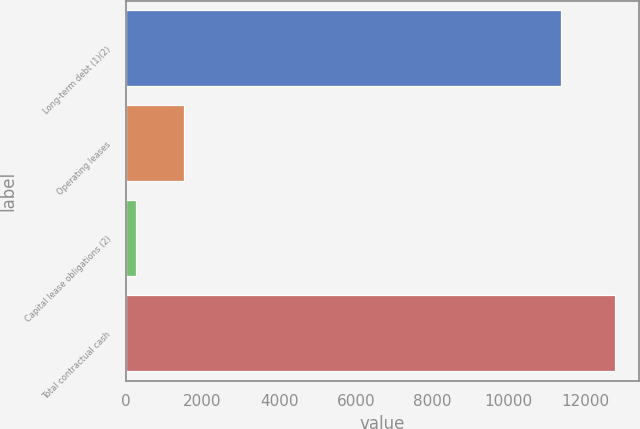<chart> <loc_0><loc_0><loc_500><loc_500><bar_chart><fcel>Long-term debt (1)(2)<fcel>Operating leases<fcel>Capital lease obligations (2)<fcel>Total contractual cash<nl><fcel>11370<fcel>1517.1<fcel>267<fcel>12768<nl></chart> 